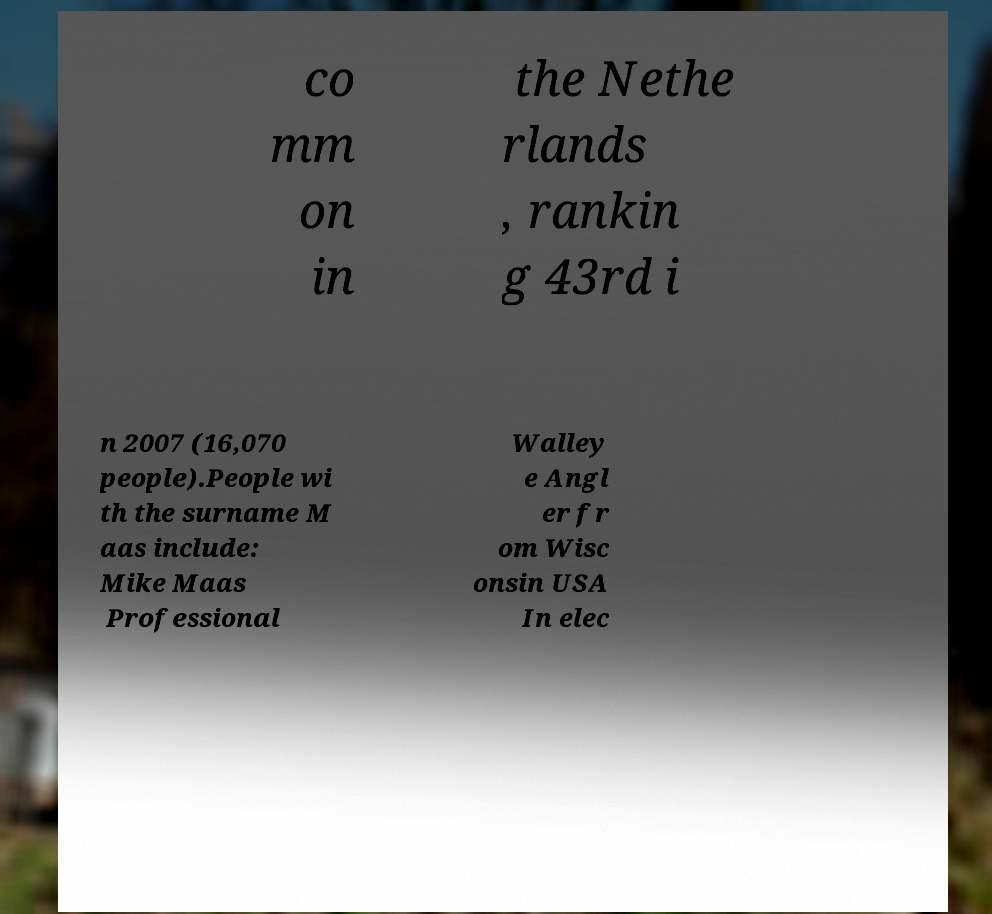What messages or text are displayed in this image? I need them in a readable, typed format. co mm on in the Nethe rlands , rankin g 43rd i n 2007 (16,070 people).People wi th the surname M aas include: Mike Maas Professional Walley e Angl er fr om Wisc onsin USA In elec 